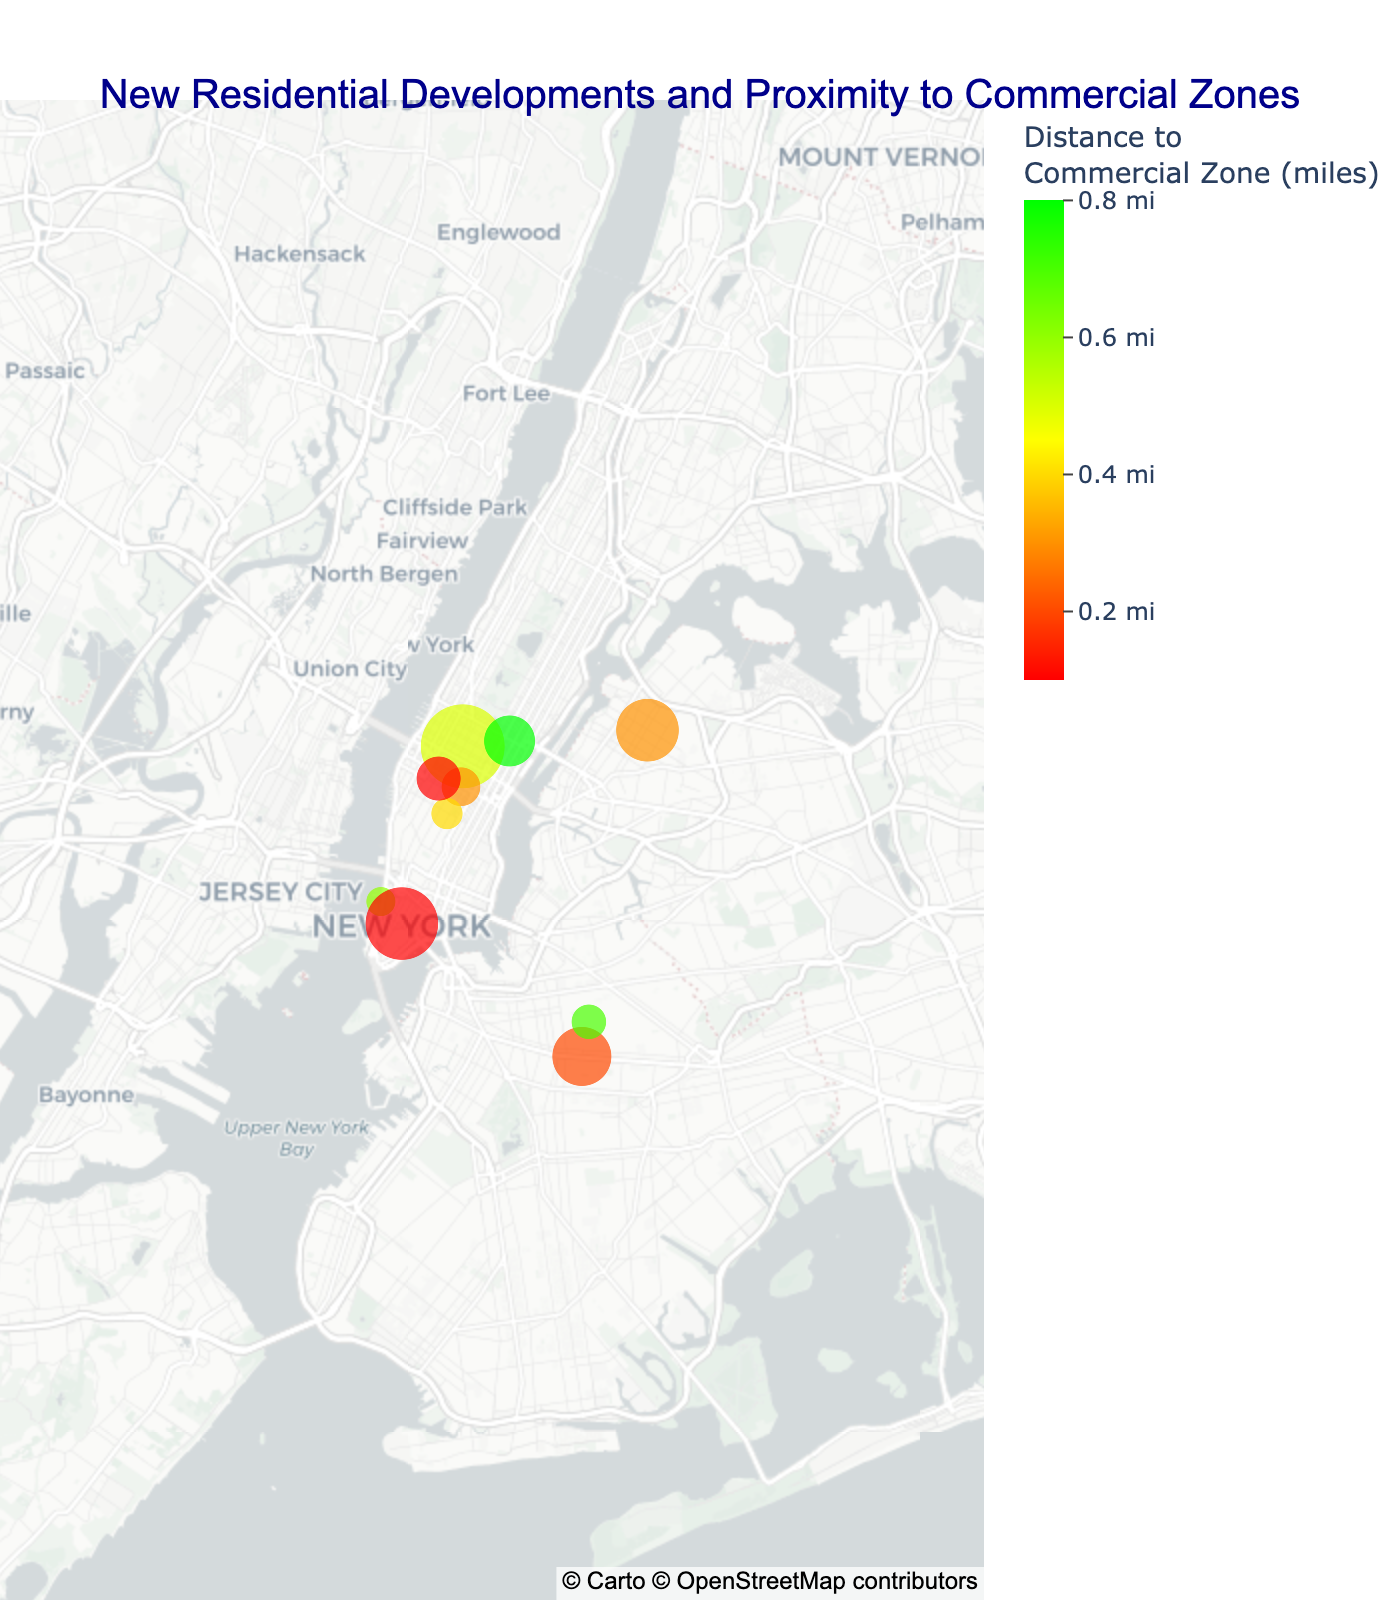What is the title of the figure? The title is typically located at the top of the figure and provides a brief description of the plot. In this case, the title reads, "New Residential Developments and Proximity to Commercial Zones."
Answer: New Residential Developments and Proximity to Commercial Zones How many residential developments are plotted on the map? Count the number of data points or markers on the map. There are 10 listed developments in the dataset, each represented by a marker.
Answer: 10 Which development is closest to a commercial zone? Locate the marker with the smallest value in the color scale indicating the distance to a commercial zone. The closest one is Hudson Yards Residences with a distance of 0.1 miles.
Answer: Hudson Yards Residences What's the average number of units for developments within 0.5 miles of a commercial zone? Identify developments with distances ≤ 0.5 miles. They are Hudson Yards Residences (1200 units), Astoria Cove (1600 units), Pacific Park Brooklyn (800 units), Murray Hill Mews (350 units), Gramercy Square (230 units), and NoMad Residences (450 units). The sum of these units is 1200 + 1600 + 800 + 350 + 230 + 450 = 4630 units. There are 6 such developments, so the average is 4630/6 ≈ 772 units.
Answer: 772 units What is the maximum distance from a residential development to a commercial zone in the figure? Examine the color scale and identify the highest value represented. The maximum distance displayed in the figure is 0.8 miles.
Answer: 0.8 miles How does the proximity to commercial zones correlate with the number of units in the developments? To deduce correlation, observe the color (distance) and size (units) simultaneously for each development. Developments appear to be denser (more units) closer to commercial zones, indicating a negative correlation where more units are found in closer proximity to commercial zones.
Answer: Negative correlation Which development has the fewest units? Locate the smallest marker on the map associated with the number of units. The smallest development is Greenwich Lane with 200 units.
Answer: Greenwich Lane How many developments are within 0.3 miles of a commercial zone? Identify all markers with a color value corresponding to distances of 0.3 miles or below. They include Hudson Yards Residences (0.1 miles), Pacific Park Brooklyn (0.2 miles), Murray Hill Mews (0.3 miles), and NoMad Residences (0.1 miles). There are 4 developments within this range.
Answer: 4 Compare the number of units between the development farthest from a commercial zone and the one closest to it. Identify the farthest development (East River Plaza, 0.8 miles, 600 units) and the closest (Hudson Yards Residences, 0.1 miles, 1200 units). The difference in units is 1200 - 600 = 600 units.
Answer: 600 units Which residential development is located at a latitude of approximately 40.6782? Match the given latitude to the data. The development at latitude 40.6782 is Pacific Park Brooklyn.
Answer: Pacific Park Brooklyn 